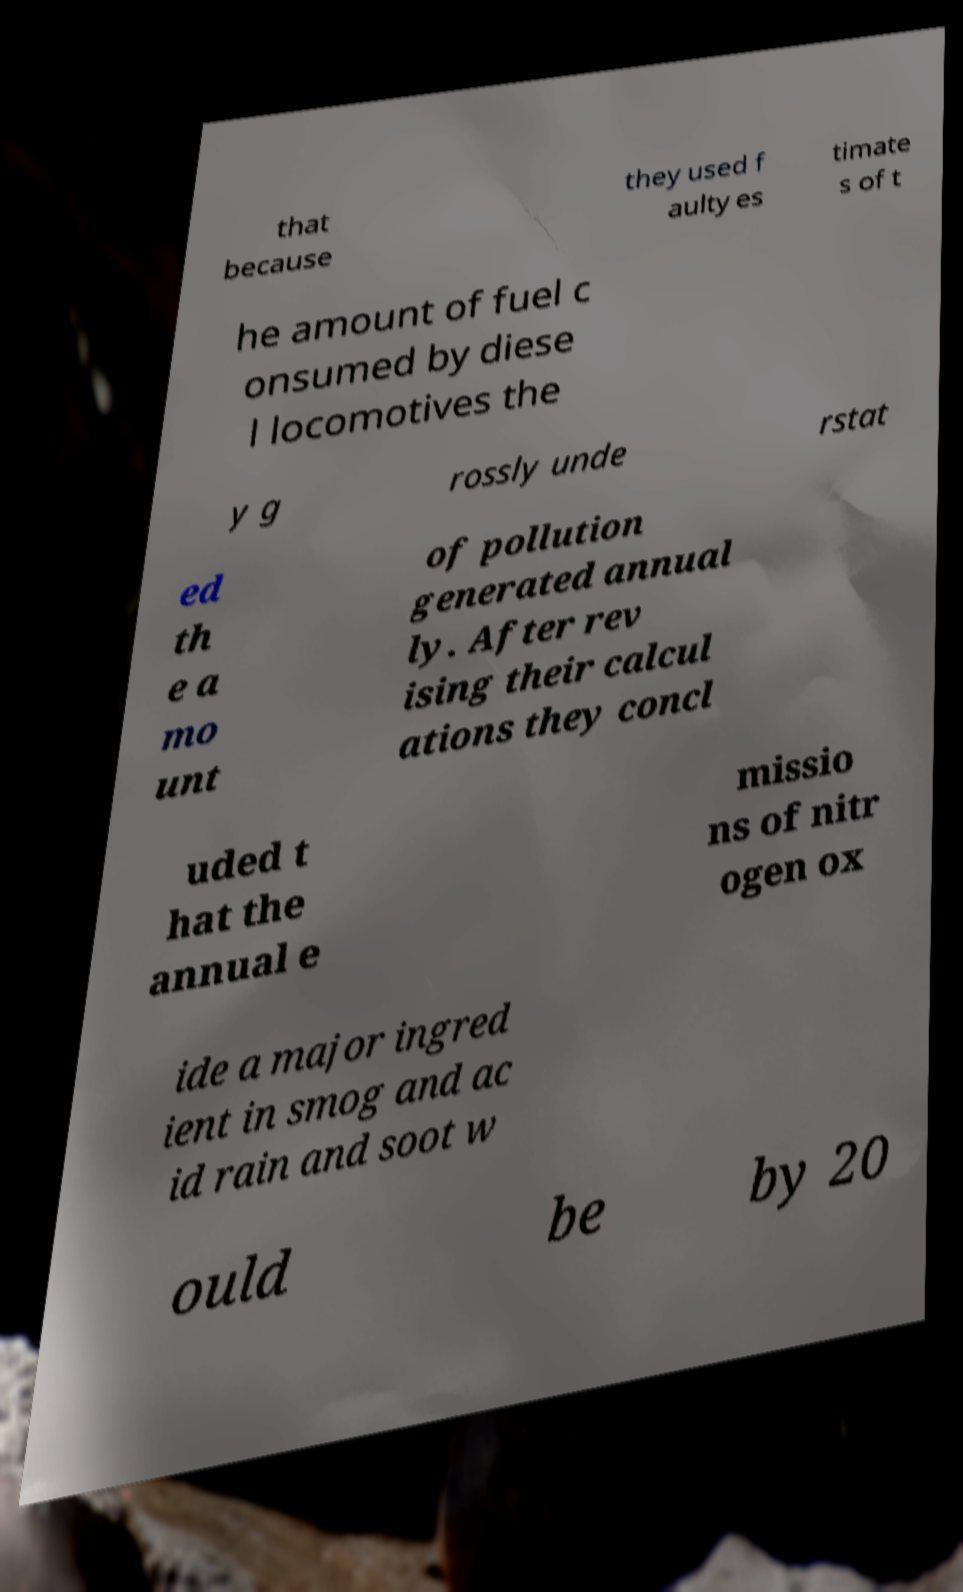Can you read and provide the text displayed in the image?This photo seems to have some interesting text. Can you extract and type it out for me? that because they used f aulty es timate s of t he amount of fuel c onsumed by diese l locomotives the y g rossly unde rstat ed th e a mo unt of pollution generated annual ly. After rev ising their calcul ations they concl uded t hat the annual e missio ns of nitr ogen ox ide a major ingred ient in smog and ac id rain and soot w ould be by 20 